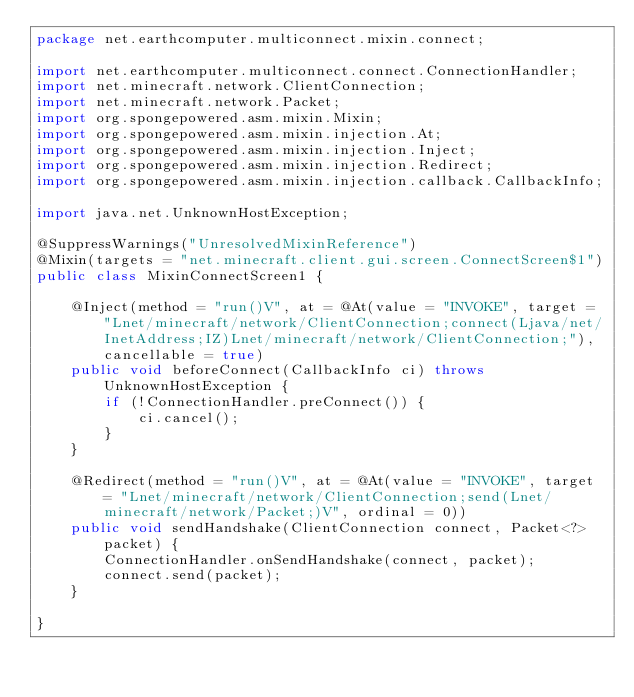<code> <loc_0><loc_0><loc_500><loc_500><_Java_>package net.earthcomputer.multiconnect.mixin.connect;

import net.earthcomputer.multiconnect.connect.ConnectionHandler;
import net.minecraft.network.ClientConnection;
import net.minecraft.network.Packet;
import org.spongepowered.asm.mixin.Mixin;
import org.spongepowered.asm.mixin.injection.At;
import org.spongepowered.asm.mixin.injection.Inject;
import org.spongepowered.asm.mixin.injection.Redirect;
import org.spongepowered.asm.mixin.injection.callback.CallbackInfo;

import java.net.UnknownHostException;

@SuppressWarnings("UnresolvedMixinReference")
@Mixin(targets = "net.minecraft.client.gui.screen.ConnectScreen$1")
public class MixinConnectScreen1 {

    @Inject(method = "run()V", at = @At(value = "INVOKE", target = "Lnet/minecraft/network/ClientConnection;connect(Ljava/net/InetAddress;IZ)Lnet/minecraft/network/ClientConnection;"), cancellable = true)
    public void beforeConnect(CallbackInfo ci) throws UnknownHostException {
        if (!ConnectionHandler.preConnect()) {
            ci.cancel();
        }
    }

    @Redirect(method = "run()V", at = @At(value = "INVOKE", target = "Lnet/minecraft/network/ClientConnection;send(Lnet/minecraft/network/Packet;)V", ordinal = 0))
    public void sendHandshake(ClientConnection connect, Packet<?> packet) {
        ConnectionHandler.onSendHandshake(connect, packet);
        connect.send(packet);
    }

}
</code> 